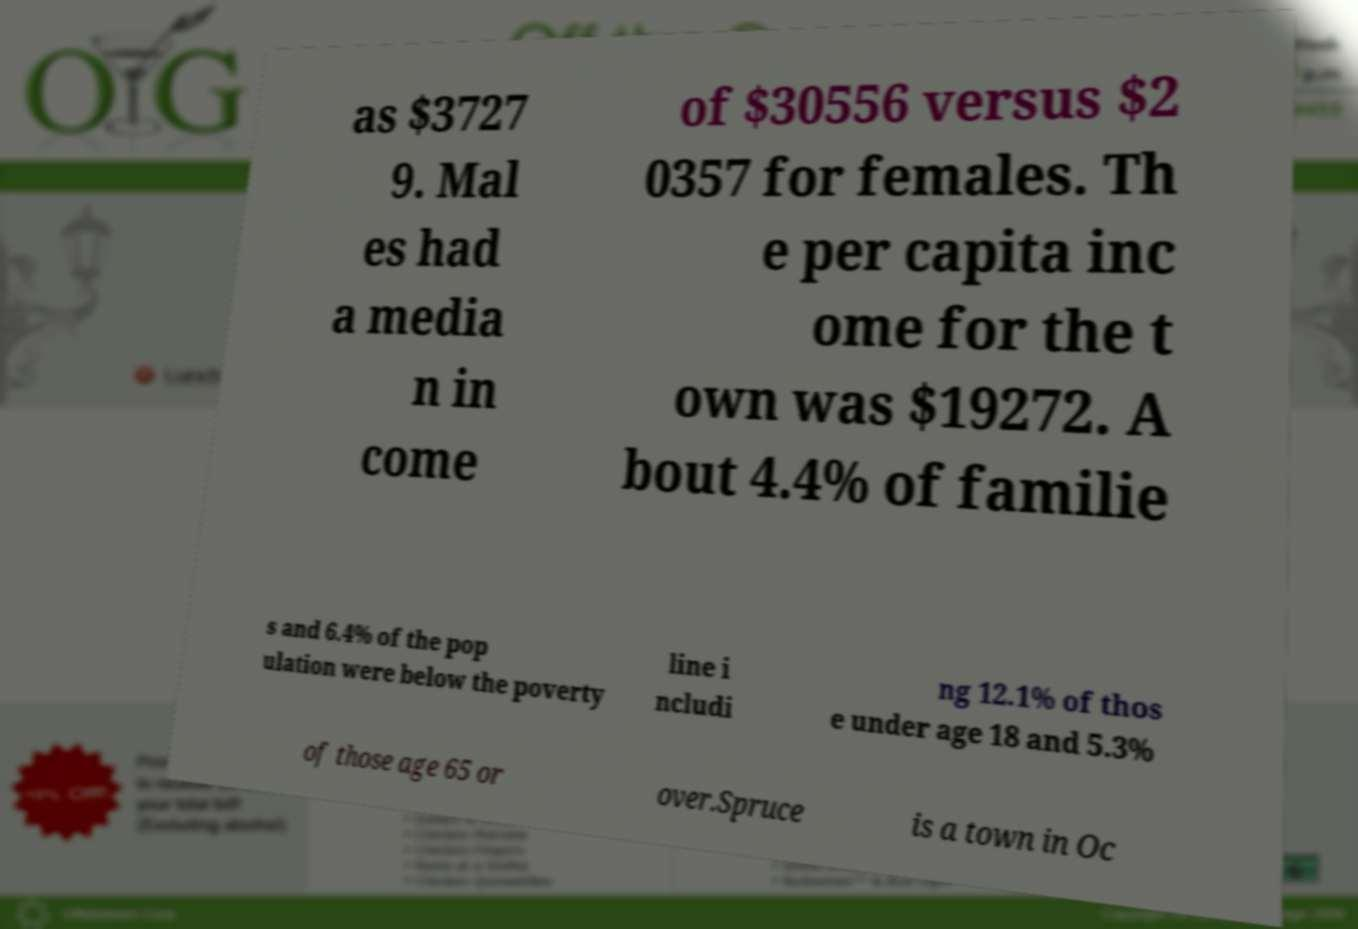Please identify and transcribe the text found in this image. as $3727 9. Mal es had a media n in come of $30556 versus $2 0357 for females. Th e per capita inc ome for the t own was $19272. A bout 4.4% of familie s and 6.4% of the pop ulation were below the poverty line i ncludi ng 12.1% of thos e under age 18 and 5.3% of those age 65 or over.Spruce is a town in Oc 